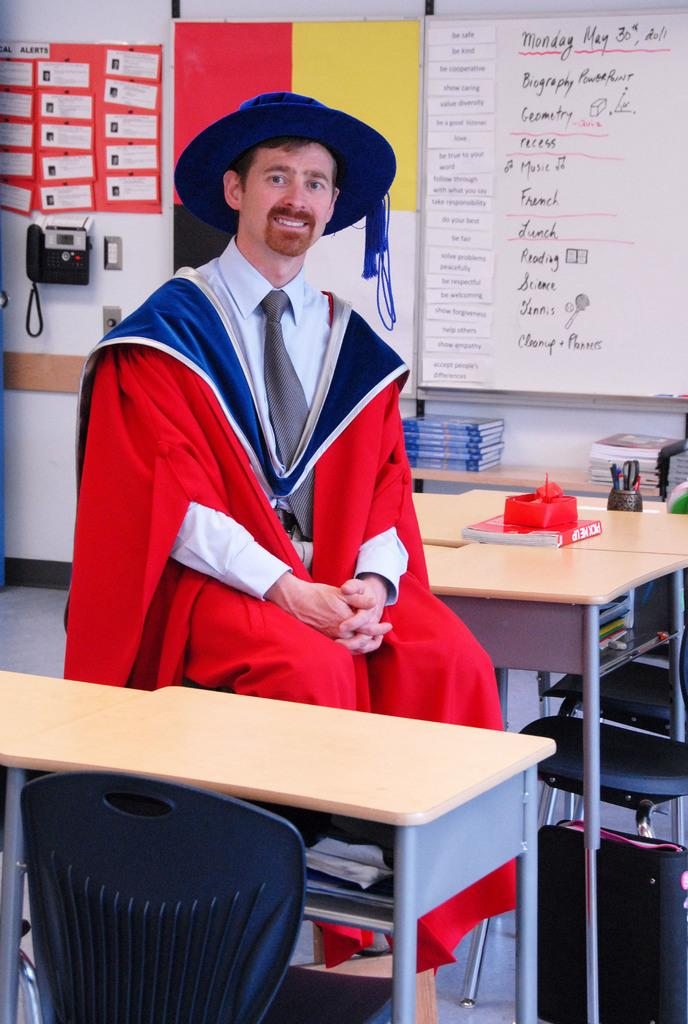What is the person in the image doing? The person is sitting on a chair in the image. What object is in front of the person? There is a table in front of the person. What type of plate is the person holding in their hand in the image? There is no plate visible in the person's hand in the image. 